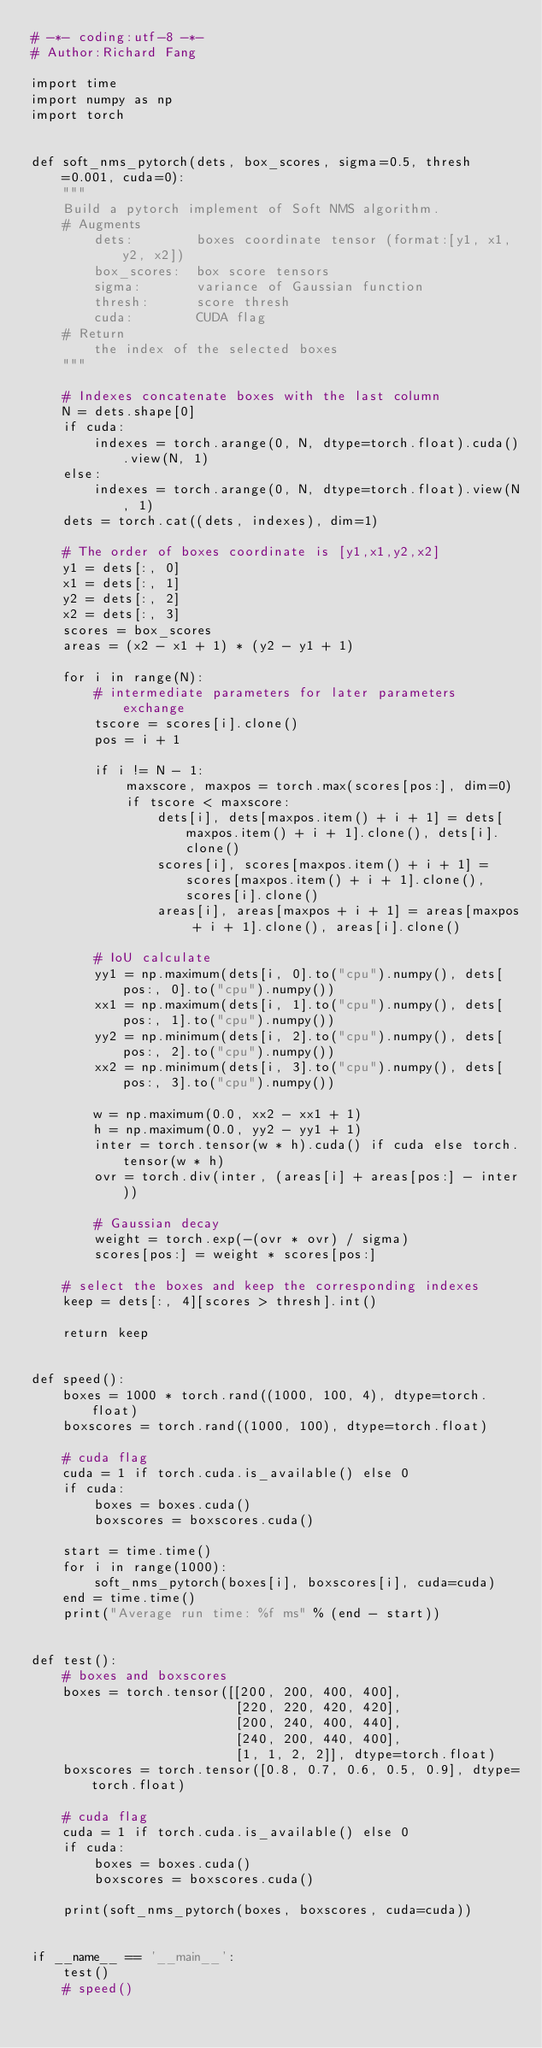<code> <loc_0><loc_0><loc_500><loc_500><_Python_># -*- coding:utf-8 -*-
# Author:Richard Fang

import time
import numpy as np
import torch


def soft_nms_pytorch(dets, box_scores, sigma=0.5, thresh=0.001, cuda=0):
    """
    Build a pytorch implement of Soft NMS algorithm.
    # Augments
        dets:        boxes coordinate tensor (format:[y1, x1, y2, x2])
        box_scores:  box score tensors
        sigma:       variance of Gaussian function
        thresh:      score thresh
        cuda:        CUDA flag
    # Return
        the index of the selected boxes
    """

    # Indexes concatenate boxes with the last column
    N = dets.shape[0]
    if cuda:
        indexes = torch.arange(0, N, dtype=torch.float).cuda().view(N, 1)
    else:
        indexes = torch.arange(0, N, dtype=torch.float).view(N, 1)
    dets = torch.cat((dets, indexes), dim=1)

    # The order of boxes coordinate is [y1,x1,y2,x2]
    y1 = dets[:, 0]
    x1 = dets[:, 1]
    y2 = dets[:, 2]
    x2 = dets[:, 3]
    scores = box_scores
    areas = (x2 - x1 + 1) * (y2 - y1 + 1)

    for i in range(N):
        # intermediate parameters for later parameters exchange
        tscore = scores[i].clone()
        pos = i + 1

        if i != N - 1:
            maxscore, maxpos = torch.max(scores[pos:], dim=0)
            if tscore < maxscore:
                dets[i], dets[maxpos.item() + i + 1] = dets[maxpos.item() + i + 1].clone(), dets[i].clone()
                scores[i], scores[maxpos.item() + i + 1] = scores[maxpos.item() + i + 1].clone(), scores[i].clone()
                areas[i], areas[maxpos + i + 1] = areas[maxpos + i + 1].clone(), areas[i].clone()

        # IoU calculate
        yy1 = np.maximum(dets[i, 0].to("cpu").numpy(), dets[pos:, 0].to("cpu").numpy())
        xx1 = np.maximum(dets[i, 1].to("cpu").numpy(), dets[pos:, 1].to("cpu").numpy())
        yy2 = np.minimum(dets[i, 2].to("cpu").numpy(), dets[pos:, 2].to("cpu").numpy())
        xx2 = np.minimum(dets[i, 3].to("cpu").numpy(), dets[pos:, 3].to("cpu").numpy())

        w = np.maximum(0.0, xx2 - xx1 + 1)
        h = np.maximum(0.0, yy2 - yy1 + 1)
        inter = torch.tensor(w * h).cuda() if cuda else torch.tensor(w * h)
        ovr = torch.div(inter, (areas[i] + areas[pos:] - inter))

        # Gaussian decay
        weight = torch.exp(-(ovr * ovr) / sigma)
        scores[pos:] = weight * scores[pos:]

    # select the boxes and keep the corresponding indexes
    keep = dets[:, 4][scores > thresh].int()

    return keep


def speed():
    boxes = 1000 * torch.rand((1000, 100, 4), dtype=torch.float)
    boxscores = torch.rand((1000, 100), dtype=torch.float)

    # cuda flag
    cuda = 1 if torch.cuda.is_available() else 0
    if cuda:
        boxes = boxes.cuda()
        boxscores = boxscores.cuda()

    start = time.time()
    for i in range(1000):
        soft_nms_pytorch(boxes[i], boxscores[i], cuda=cuda)
    end = time.time()
    print("Average run time: %f ms" % (end - start))


def test():
    # boxes and boxscores
    boxes = torch.tensor([[200, 200, 400, 400],
                          [220, 220, 420, 420],
                          [200, 240, 400, 440],
                          [240, 200, 440, 400],
                          [1, 1, 2, 2]], dtype=torch.float)
    boxscores = torch.tensor([0.8, 0.7, 0.6, 0.5, 0.9], dtype=torch.float)

    # cuda flag
    cuda = 1 if torch.cuda.is_available() else 0
    if cuda:
        boxes = boxes.cuda()
        boxscores = boxscores.cuda()

    print(soft_nms_pytorch(boxes, boxscores, cuda=cuda))


if __name__ == '__main__':
    test()
    # speed()</code> 